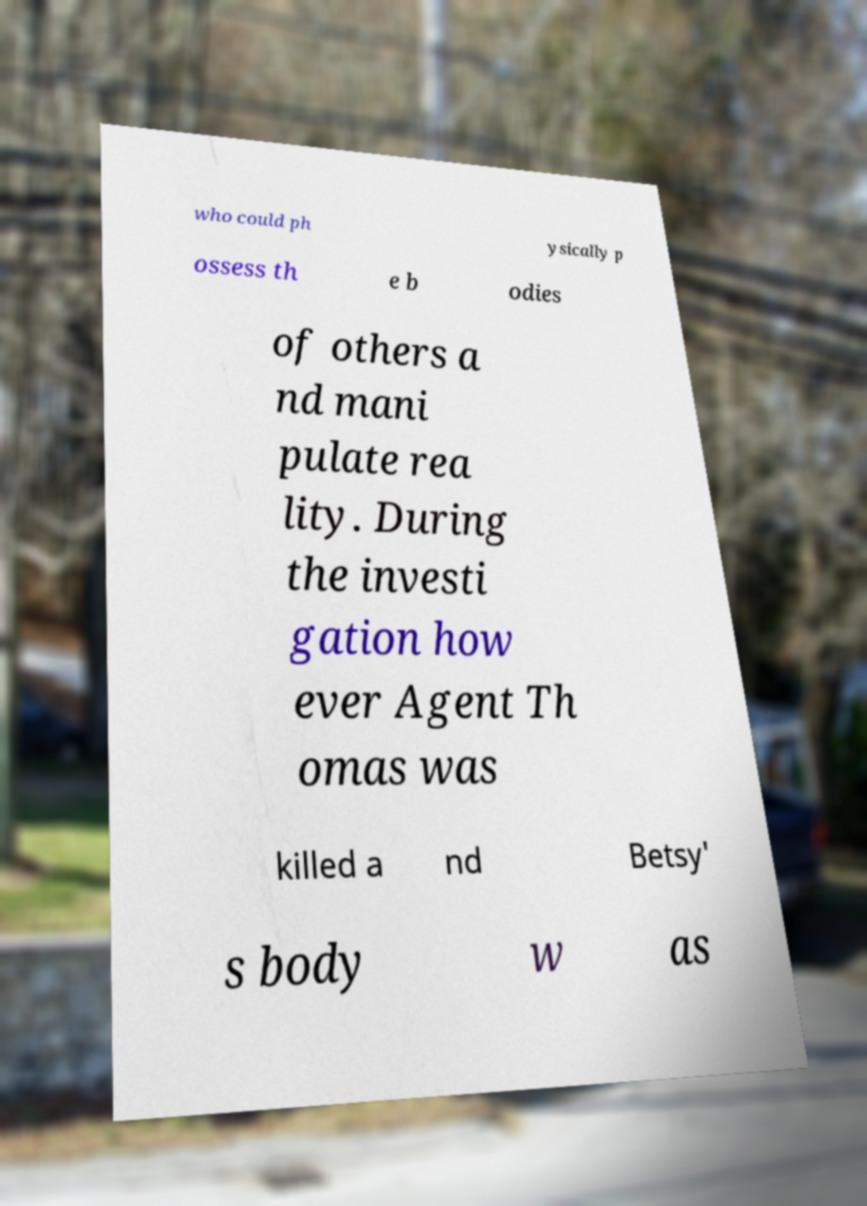What messages or text are displayed in this image? I need them in a readable, typed format. who could ph ysically p ossess th e b odies of others a nd mani pulate rea lity. During the investi gation how ever Agent Th omas was killed a nd Betsy' s body w as 